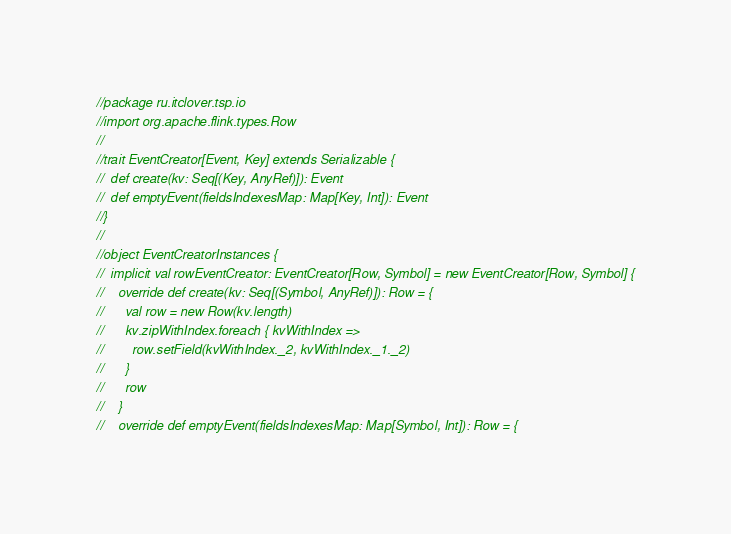<code> <loc_0><loc_0><loc_500><loc_500><_Scala_>//package ru.itclover.tsp.io
//import org.apache.flink.types.Row
//
//trait EventCreator[Event, Key] extends Serializable {
//  def create(kv: Seq[(Key, AnyRef)]): Event
//  def emptyEvent(fieldsIndexesMap: Map[Key, Int]): Event
//}
//
//object EventCreatorInstances {
//  implicit val rowEventCreator: EventCreator[Row, Symbol] = new EventCreator[Row, Symbol] {
//    override def create(kv: Seq[(Symbol, AnyRef)]): Row = {
//      val row = new Row(kv.length)
//      kv.zipWithIndex.foreach { kvWithIndex =>
//        row.setField(kvWithIndex._2, kvWithIndex._1._2)
//      }
//      row
//    }
//    override def emptyEvent(fieldsIndexesMap: Map[Symbol, Int]): Row = {</code> 